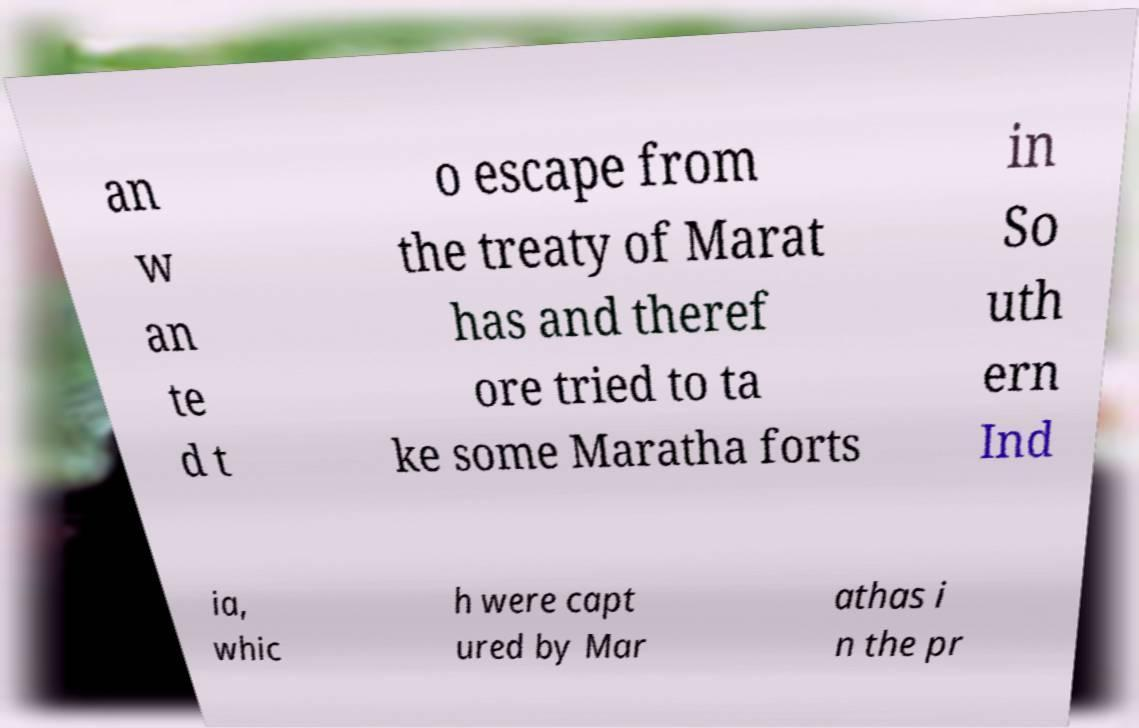Can you read and provide the text displayed in the image?This photo seems to have some interesting text. Can you extract and type it out for me? an w an te d t o escape from the treaty of Marat has and theref ore tried to ta ke some Maratha forts in So uth ern Ind ia, whic h were capt ured by Mar athas i n the pr 